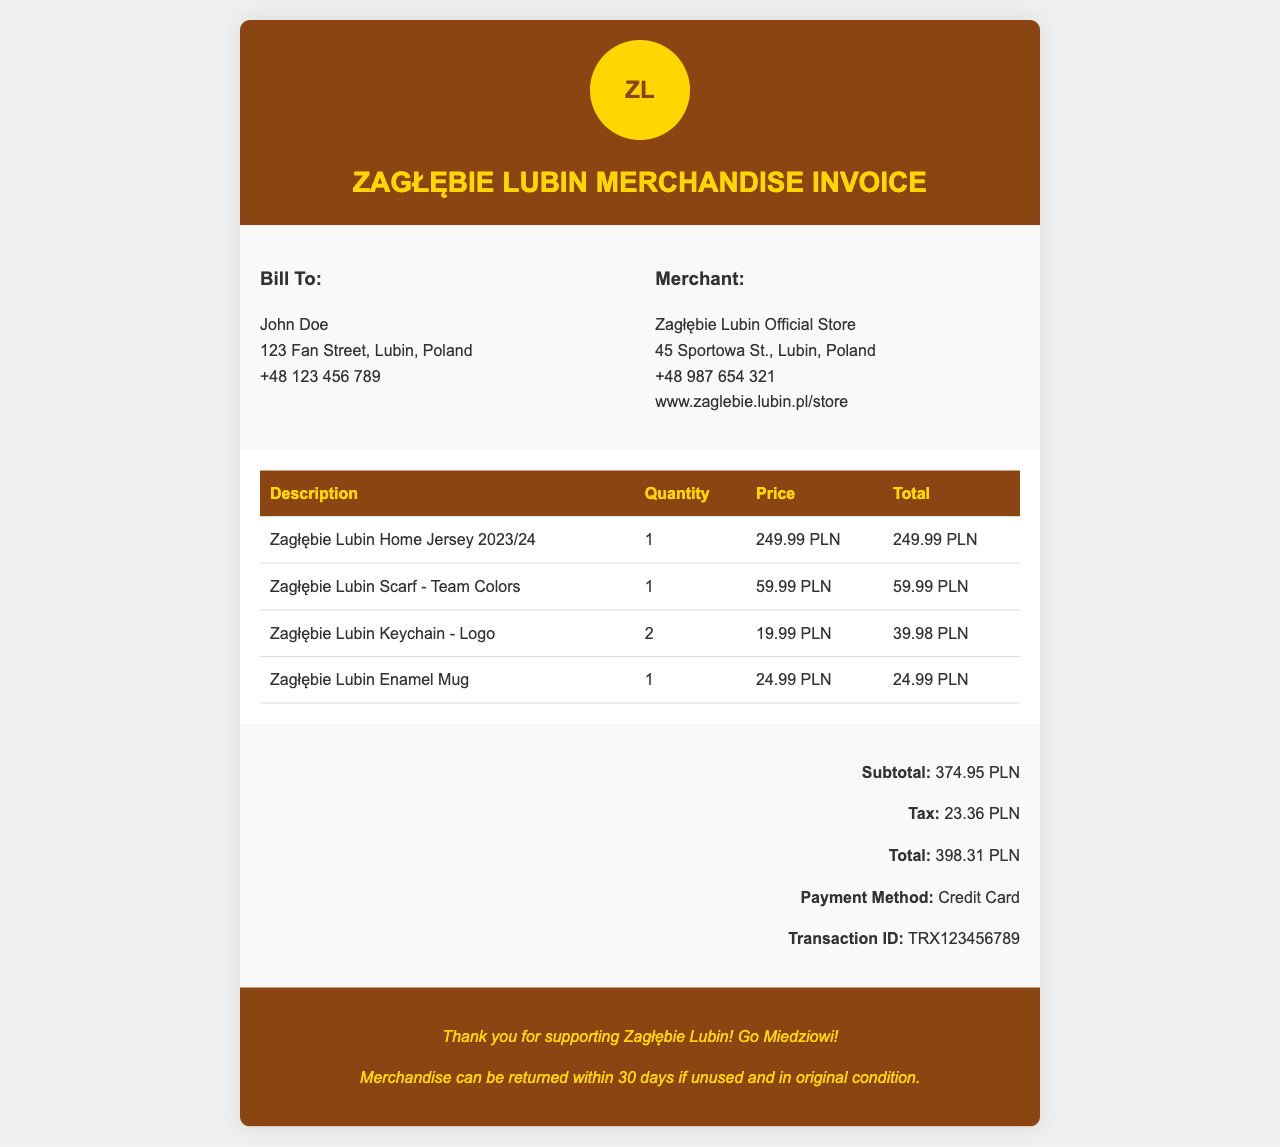What is the name of the customer? The customer's name is provided in the "Bill To" section of the invoice.
Answer: John Doe What is the total cost of the merchandise? The total cost is listed in the invoice summary section under "Total."
Answer: 398.31 PLN How many Zagłębie Lubin Keychains were purchased? The quantity of Zagłębie Lubin Keychains can be found in the itemized list of the invoice.
Answer: 2 What is the price of the Zeagłębie Lubin Home Jersey 2023/24? The price is indicated in the "Price" column of the invoice item table for the jersey.
Answer: 249.99 PLN What payment method was used for the purchase? The payment method is mentioned in the invoice summary section.
Answer: Credit Card What is the tax amount applied to the invoice? The tax amount is detailed in the invoice summary section.
Answer: 23.36 PLN Which item has the highest price? The highest priced item can be determined from the itemized list in the document.
Answer: Zagłębie Lubin Home Jersey 2023/24 What is the return policy for the merchandise? The return policy is specified in the invoice footer.
Answer: 30 days if unused and in original condition What is the transaction ID for this purchase? The transaction ID is provided in the invoice summary section.
Answer: TRX123456789 